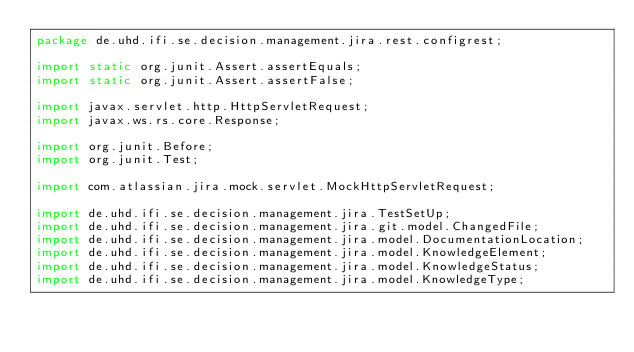<code> <loc_0><loc_0><loc_500><loc_500><_Java_>package de.uhd.ifi.se.decision.management.jira.rest.configrest;

import static org.junit.Assert.assertEquals;
import static org.junit.Assert.assertFalse;

import javax.servlet.http.HttpServletRequest;
import javax.ws.rs.core.Response;

import org.junit.Before;
import org.junit.Test;

import com.atlassian.jira.mock.servlet.MockHttpServletRequest;

import de.uhd.ifi.se.decision.management.jira.TestSetUp;
import de.uhd.ifi.se.decision.management.jira.git.model.ChangedFile;
import de.uhd.ifi.se.decision.management.jira.model.DocumentationLocation;
import de.uhd.ifi.se.decision.management.jira.model.KnowledgeElement;
import de.uhd.ifi.se.decision.management.jira.model.KnowledgeStatus;
import de.uhd.ifi.se.decision.management.jira.model.KnowledgeType;</code> 